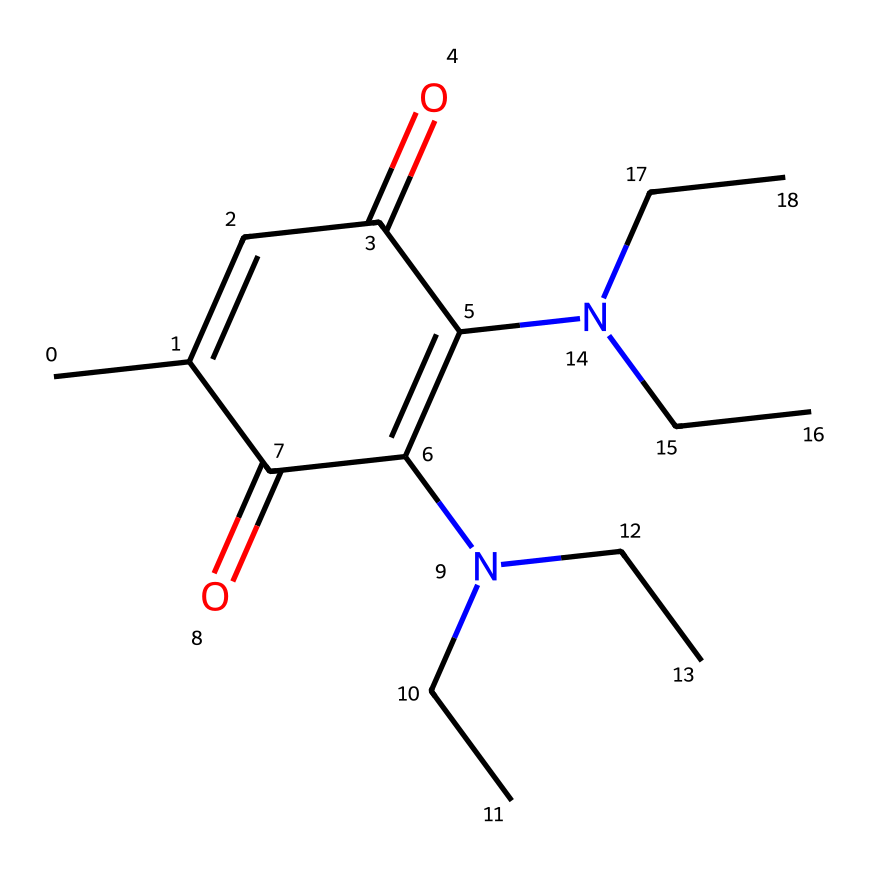What is the number of nitrogen atoms in this structure? The chemical structure shows two nitrogen atoms represented by the "N" notation in the SMILES string.
Answer: 2 What functional group is present in this compound? The presence of a "C(=O)" notation indicates the carbonyl group, which is characteristic of ketones.
Answer: ketone How many rings are present in this molecule? The notation "C1" and the subsequent "C1=O" indicates a ring structure that includes one cyclic portion.
Answer: 1 What type of substitution does the nitrogen undergo in this molecule? The presence of "N(CC)CC" suggests that the nitrogen is tertiary, bonded to three carbon groups.
Answer: tertiary What is the total number of carbon atoms in this structure? By counting each "C" in the SMILES string, including those involved in the ring and side chains, we find there are 13 carbon atoms in total.
Answer: 13 Does this compound have any double bonds? The structure contains several double bonds, specifically indicated by the "C=C" and "C=O" notations present in the SMILES.
Answer: yes How many ketone functional groups does the structure contain? The "C(=O)" notation appears twice in the compound representing two distinct ketone groups, indicating its functionality.
Answer: 2 